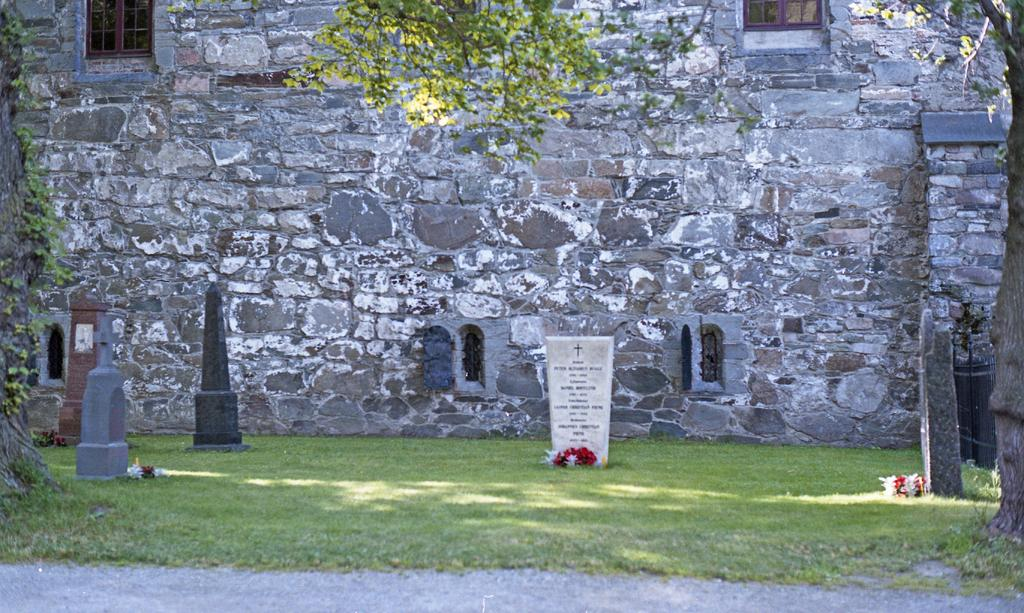What is the main setting of the image? There is a graveyard in the image. How do the memorials in the graveyard differ from one another? The memorials in the graveyard have different colors. What type of decoration can be seen in the image? There are flowers in the image. What type of natural elements are present in the image? There are trees in the image. What architectural feature is visible in the background of the image? There is a wall with windows in the background of the image. What type of lace is used to decorate the wealthiest memorial in the image? There is no mention of lace or wealth in the image; it features a graveyard with different colored memorials, flowers, trees, and a wall with windows in the background. 